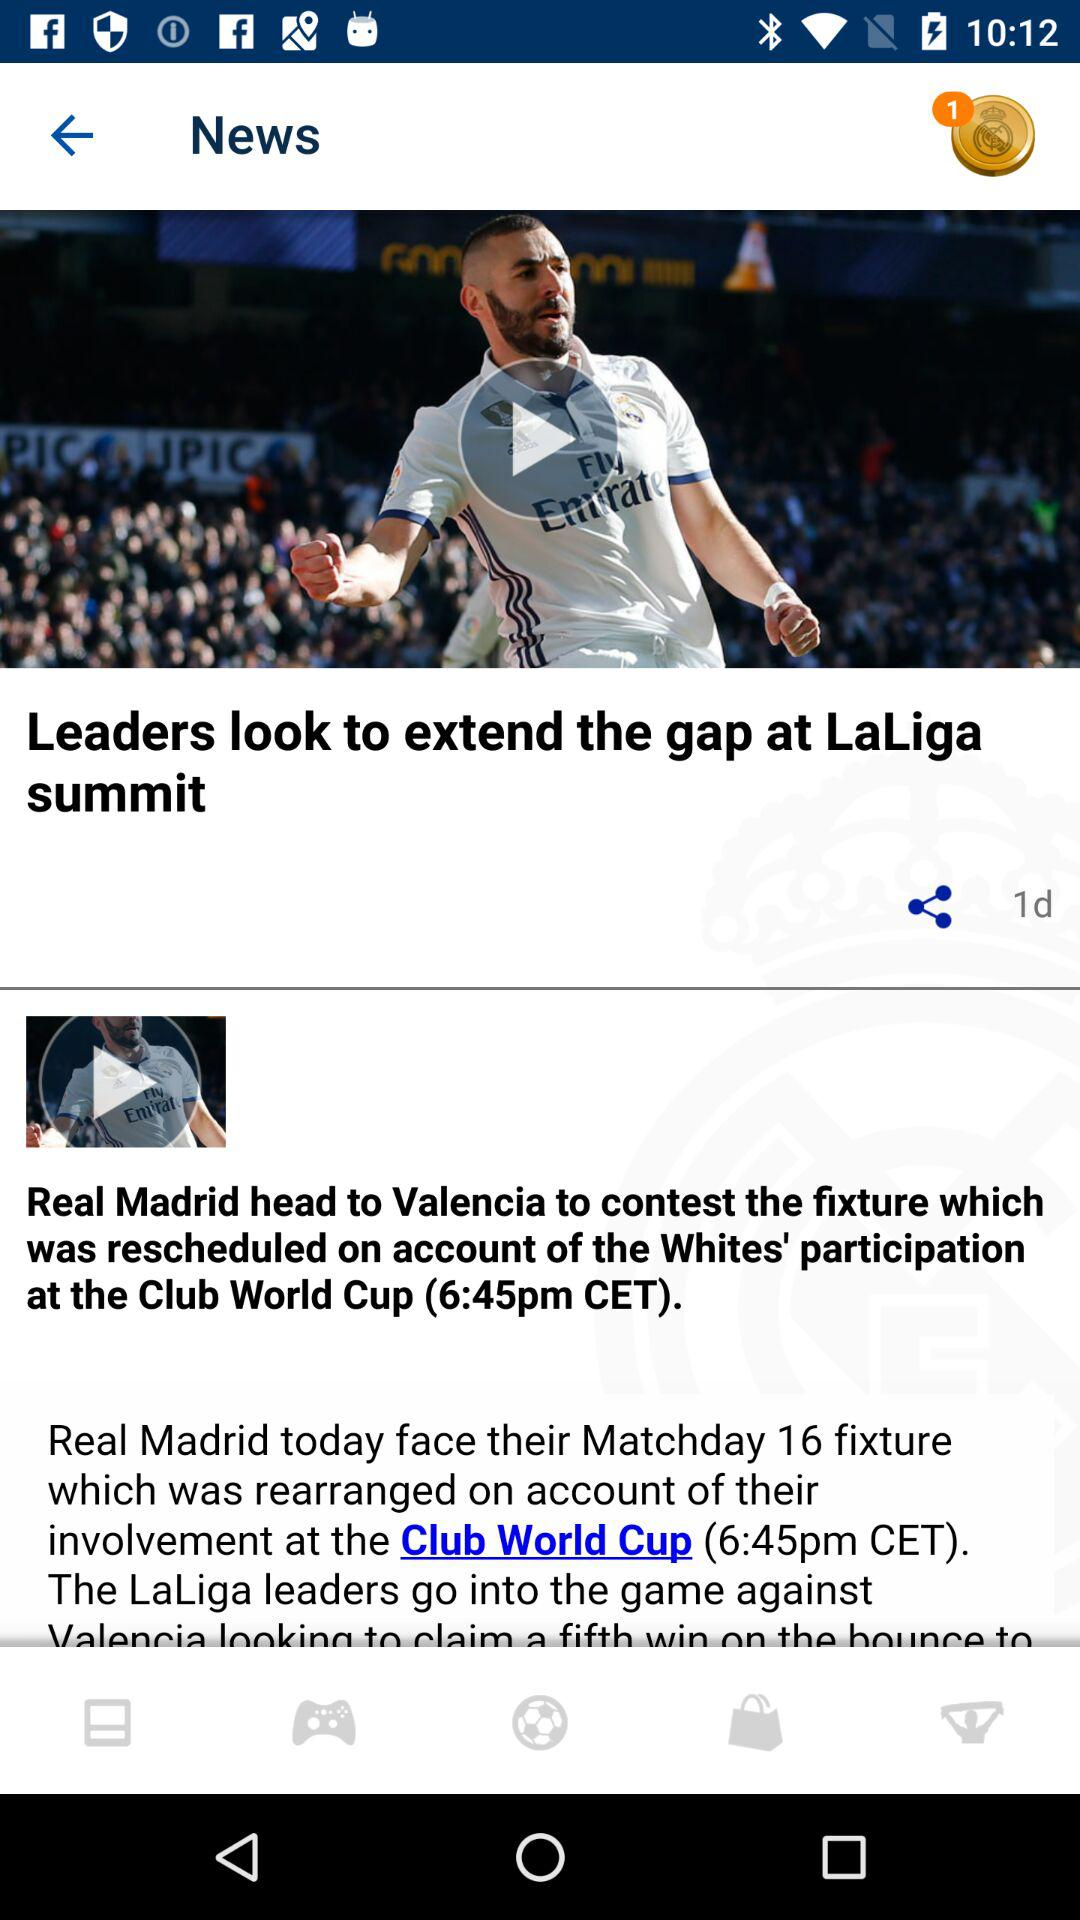When was the post "Leaders look to extend the gap at LaLiga summit" uploaded? The post was uploaded 1 day ago. 